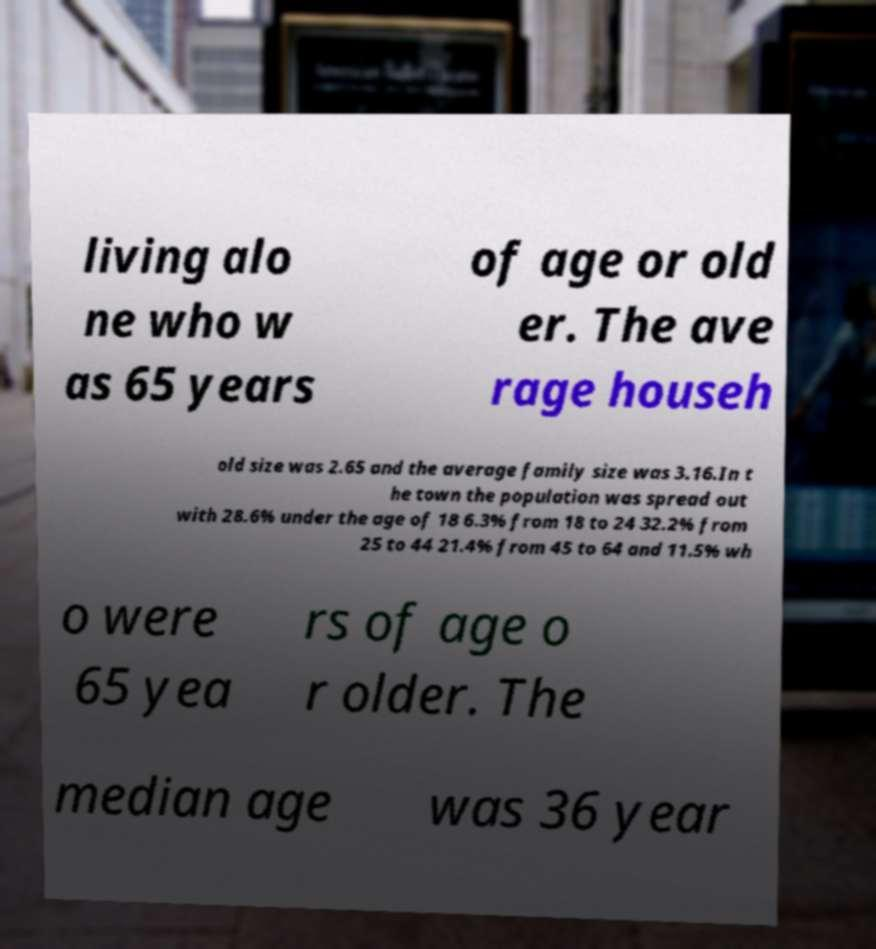For documentation purposes, I need the text within this image transcribed. Could you provide that? living alo ne who w as 65 years of age or old er. The ave rage househ old size was 2.65 and the average family size was 3.16.In t he town the population was spread out with 28.6% under the age of 18 6.3% from 18 to 24 32.2% from 25 to 44 21.4% from 45 to 64 and 11.5% wh o were 65 yea rs of age o r older. The median age was 36 year 